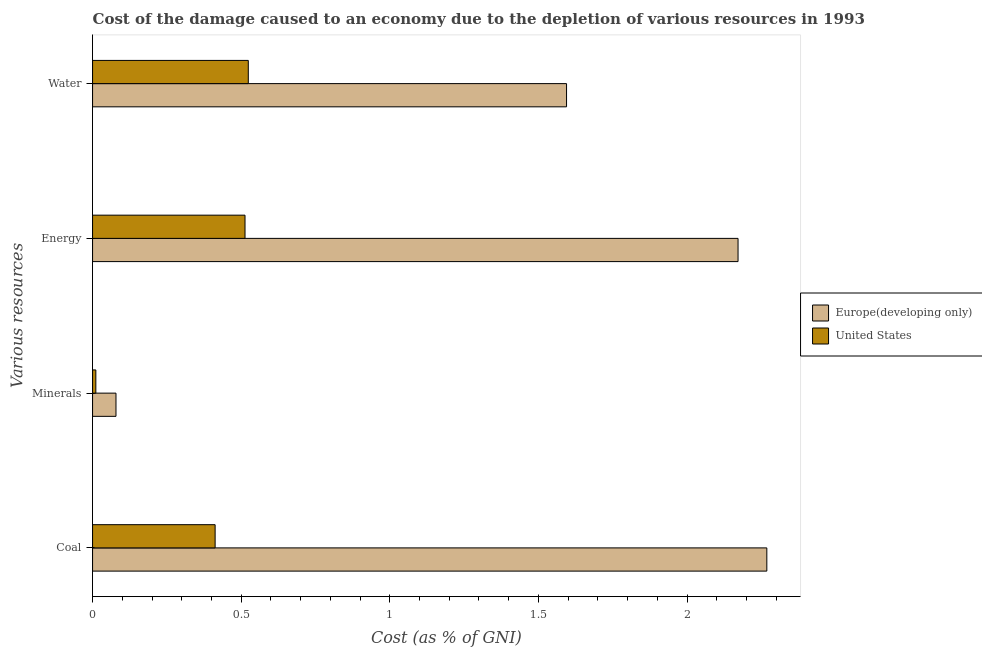How many different coloured bars are there?
Keep it short and to the point. 2. How many groups of bars are there?
Give a very brief answer. 4. Are the number of bars per tick equal to the number of legend labels?
Your response must be concise. Yes. How many bars are there on the 4th tick from the bottom?
Offer a terse response. 2. What is the label of the 2nd group of bars from the top?
Make the answer very short. Energy. What is the cost of damage due to depletion of minerals in United States?
Offer a very short reply. 0.01. Across all countries, what is the maximum cost of damage due to depletion of minerals?
Give a very brief answer. 0.08. Across all countries, what is the minimum cost of damage due to depletion of water?
Provide a short and direct response. 0.52. In which country was the cost of damage due to depletion of coal maximum?
Offer a terse response. Europe(developing only). In which country was the cost of damage due to depletion of coal minimum?
Provide a succinct answer. United States. What is the total cost of damage due to depletion of minerals in the graph?
Offer a terse response. 0.09. What is the difference between the cost of damage due to depletion of energy in Europe(developing only) and that in United States?
Offer a very short reply. 1.66. What is the difference between the cost of damage due to depletion of minerals in Europe(developing only) and the cost of damage due to depletion of coal in United States?
Your answer should be compact. -0.33. What is the average cost of damage due to depletion of water per country?
Your answer should be compact. 1.06. What is the difference between the cost of damage due to depletion of coal and cost of damage due to depletion of energy in United States?
Give a very brief answer. -0.1. What is the ratio of the cost of damage due to depletion of energy in United States to that in Europe(developing only)?
Offer a terse response. 0.24. Is the difference between the cost of damage due to depletion of energy in Europe(developing only) and United States greater than the difference between the cost of damage due to depletion of minerals in Europe(developing only) and United States?
Keep it short and to the point. Yes. What is the difference between the highest and the second highest cost of damage due to depletion of water?
Provide a succinct answer. 1.07. What is the difference between the highest and the lowest cost of damage due to depletion of coal?
Your response must be concise. 1.86. Is the sum of the cost of damage due to depletion of water in United States and Europe(developing only) greater than the maximum cost of damage due to depletion of minerals across all countries?
Make the answer very short. Yes. What does the 1st bar from the top in Energy represents?
Keep it short and to the point. United States. How many bars are there?
Keep it short and to the point. 8. How many countries are there in the graph?
Give a very brief answer. 2. Does the graph contain any zero values?
Ensure brevity in your answer.  No. Does the graph contain grids?
Your response must be concise. No. How many legend labels are there?
Your answer should be compact. 2. How are the legend labels stacked?
Keep it short and to the point. Vertical. What is the title of the graph?
Your answer should be very brief. Cost of the damage caused to an economy due to the depletion of various resources in 1993 . Does "Bermuda" appear as one of the legend labels in the graph?
Your response must be concise. No. What is the label or title of the X-axis?
Offer a terse response. Cost (as % of GNI). What is the label or title of the Y-axis?
Your answer should be compact. Various resources. What is the Cost (as % of GNI) in Europe(developing only) in Coal?
Provide a short and direct response. 2.27. What is the Cost (as % of GNI) of United States in Coal?
Your answer should be compact. 0.41. What is the Cost (as % of GNI) in Europe(developing only) in Minerals?
Your response must be concise. 0.08. What is the Cost (as % of GNI) of United States in Minerals?
Provide a succinct answer. 0.01. What is the Cost (as % of GNI) in Europe(developing only) in Energy?
Make the answer very short. 2.17. What is the Cost (as % of GNI) in United States in Energy?
Offer a terse response. 0.51. What is the Cost (as % of GNI) in Europe(developing only) in Water?
Provide a succinct answer. 1.59. What is the Cost (as % of GNI) in United States in Water?
Provide a short and direct response. 0.52. Across all Various resources, what is the maximum Cost (as % of GNI) of Europe(developing only)?
Make the answer very short. 2.27. Across all Various resources, what is the maximum Cost (as % of GNI) in United States?
Make the answer very short. 0.52. Across all Various resources, what is the minimum Cost (as % of GNI) in Europe(developing only)?
Your answer should be very brief. 0.08. Across all Various resources, what is the minimum Cost (as % of GNI) in United States?
Make the answer very short. 0.01. What is the total Cost (as % of GNI) of Europe(developing only) in the graph?
Offer a very short reply. 6.11. What is the total Cost (as % of GNI) of United States in the graph?
Keep it short and to the point. 1.46. What is the difference between the Cost (as % of GNI) in Europe(developing only) in Coal and that in Minerals?
Give a very brief answer. 2.19. What is the difference between the Cost (as % of GNI) in United States in Coal and that in Minerals?
Give a very brief answer. 0.4. What is the difference between the Cost (as % of GNI) in Europe(developing only) in Coal and that in Energy?
Offer a terse response. 0.1. What is the difference between the Cost (as % of GNI) in United States in Coal and that in Energy?
Provide a succinct answer. -0.1. What is the difference between the Cost (as % of GNI) of Europe(developing only) in Coal and that in Water?
Offer a terse response. 0.67. What is the difference between the Cost (as % of GNI) of United States in Coal and that in Water?
Your answer should be very brief. -0.11. What is the difference between the Cost (as % of GNI) in Europe(developing only) in Minerals and that in Energy?
Provide a short and direct response. -2.09. What is the difference between the Cost (as % of GNI) in United States in Minerals and that in Energy?
Ensure brevity in your answer.  -0.5. What is the difference between the Cost (as % of GNI) in Europe(developing only) in Minerals and that in Water?
Offer a terse response. -1.52. What is the difference between the Cost (as % of GNI) in United States in Minerals and that in Water?
Provide a short and direct response. -0.51. What is the difference between the Cost (as % of GNI) of Europe(developing only) in Energy and that in Water?
Provide a short and direct response. 0.58. What is the difference between the Cost (as % of GNI) of United States in Energy and that in Water?
Your answer should be very brief. -0.01. What is the difference between the Cost (as % of GNI) in Europe(developing only) in Coal and the Cost (as % of GNI) in United States in Minerals?
Offer a very short reply. 2.26. What is the difference between the Cost (as % of GNI) of Europe(developing only) in Coal and the Cost (as % of GNI) of United States in Energy?
Provide a succinct answer. 1.76. What is the difference between the Cost (as % of GNI) in Europe(developing only) in Coal and the Cost (as % of GNI) in United States in Water?
Offer a terse response. 1.74. What is the difference between the Cost (as % of GNI) of Europe(developing only) in Minerals and the Cost (as % of GNI) of United States in Energy?
Your answer should be very brief. -0.43. What is the difference between the Cost (as % of GNI) of Europe(developing only) in Minerals and the Cost (as % of GNI) of United States in Water?
Your response must be concise. -0.45. What is the difference between the Cost (as % of GNI) in Europe(developing only) in Energy and the Cost (as % of GNI) in United States in Water?
Make the answer very short. 1.65. What is the average Cost (as % of GNI) of Europe(developing only) per Various resources?
Give a very brief answer. 1.53. What is the average Cost (as % of GNI) of United States per Various resources?
Your response must be concise. 0.37. What is the difference between the Cost (as % of GNI) in Europe(developing only) and Cost (as % of GNI) in United States in Coal?
Provide a short and direct response. 1.86. What is the difference between the Cost (as % of GNI) in Europe(developing only) and Cost (as % of GNI) in United States in Minerals?
Your answer should be compact. 0.07. What is the difference between the Cost (as % of GNI) of Europe(developing only) and Cost (as % of GNI) of United States in Energy?
Ensure brevity in your answer.  1.66. What is the difference between the Cost (as % of GNI) of Europe(developing only) and Cost (as % of GNI) of United States in Water?
Provide a short and direct response. 1.07. What is the ratio of the Cost (as % of GNI) of Europe(developing only) in Coal to that in Minerals?
Your answer should be very brief. 28.8. What is the ratio of the Cost (as % of GNI) of United States in Coal to that in Minerals?
Keep it short and to the point. 37.39. What is the ratio of the Cost (as % of GNI) in Europe(developing only) in Coal to that in Energy?
Offer a very short reply. 1.04. What is the ratio of the Cost (as % of GNI) in United States in Coal to that in Energy?
Your answer should be compact. 0.8. What is the ratio of the Cost (as % of GNI) of Europe(developing only) in Coal to that in Water?
Your response must be concise. 1.42. What is the ratio of the Cost (as % of GNI) of United States in Coal to that in Water?
Your answer should be compact. 0.79. What is the ratio of the Cost (as % of GNI) of Europe(developing only) in Minerals to that in Energy?
Provide a succinct answer. 0.04. What is the ratio of the Cost (as % of GNI) in United States in Minerals to that in Energy?
Your answer should be compact. 0.02. What is the ratio of the Cost (as % of GNI) in Europe(developing only) in Minerals to that in Water?
Make the answer very short. 0.05. What is the ratio of the Cost (as % of GNI) in United States in Minerals to that in Water?
Give a very brief answer. 0.02. What is the ratio of the Cost (as % of GNI) of Europe(developing only) in Energy to that in Water?
Your answer should be compact. 1.36. What is the ratio of the Cost (as % of GNI) of United States in Energy to that in Water?
Provide a succinct answer. 0.98. What is the difference between the highest and the second highest Cost (as % of GNI) of Europe(developing only)?
Your answer should be compact. 0.1. What is the difference between the highest and the second highest Cost (as % of GNI) of United States?
Provide a succinct answer. 0.01. What is the difference between the highest and the lowest Cost (as % of GNI) of Europe(developing only)?
Ensure brevity in your answer.  2.19. What is the difference between the highest and the lowest Cost (as % of GNI) of United States?
Keep it short and to the point. 0.51. 